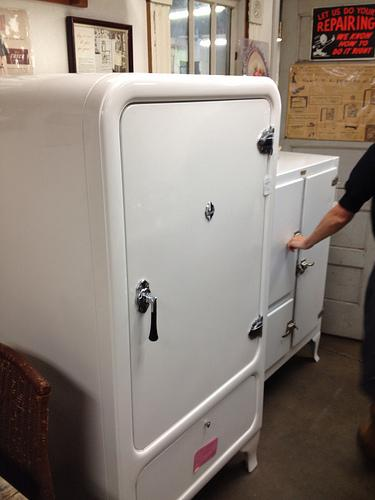Describe the feeling or mood of this image based on the objects present. The image gives a vintage and nostalgic feel due to the antique white refrigerator, the wooden picture frame, and the old-fashioned cupboard. What is the color and material of the handle on the cupboard? The handle is silver in color and made of steel. Identify the type, color, and position of the objects and appliances in the scene. There's a white cupboard with a silver handle, an antique white refrigerator with a pink post-it, a brown chair next to them, a wooden picture frame, a three-pane window, and a sign on the wall with red letters. Mention three significant characteristics of the cupboard and its door. The cupboard is white, has a silver steel handle, and the bottom door of the cupboard has gold hinges. Explain what the person in the image is doing while mentioning their outfit. A person wearing a black shirt is reaching and holding the silver handle of the cupboard, possibly trying to open it. Find the details that describe the window and the sign on the wall. The window has three panes and is positioned above the cabinet. The sign on the wall has red lettering. List three noticeable details about the refrigerator. The refrigerator is an antique, white in color, and has a pink post-it on the bottom door. Point out any unique features and their colors found on the refrigerator. The refrigerator has a pink post-it and a silver handle which contrasts with its white color. What actions are being taken by the person, and what specific object are they interacting with? The person is reaching for and holding the silver handle on the cupboard, apparently trying to open it. Count the number of objects in the image and describe their color and function. There are 9 objects: a white cupboard to store items, a silver handle for opening it, a white antique refrigerator for keeping food, a pink post-it for notes, a brown chair to sit on, a window to let in sunlight, a wooden picture frame for decoration, and a sign with red letters for information. What type of shirt is the person wearing? black shirt Describe any notable features of the door on the cupboard. It has metal or gold hinges. What is the overall style of the kitchen appliances? antique or vintage Describe the material and color of the handle on the cupboard. The handle is silver and made of metal or steel. What is written on the pink post-it on the refrigerator? The text on the post-it is not provided or visible. Explain how you would interpret the scene displayed in the image. A person in a retro-style kitchen is attempting to open a cupboard or refrigerator with a white antique design while surrounded by various other items. What are the key elements in the background of the image? a window, a picture frame, and a sign on the wall Examine the color and material of the appliance. The appliance is white and made of metal. Which feature of the refrigerator indicates its age? The antique design. Identify the color of the chair next to the cupboard. brown Which one of the following objects is on the refrigerator? A) Green Sticker B) Pink Post-it C) Orange Magnet B) Pink Post-it Describe the emotions visible on the person's face in the image. Not applicable, the image does not show a person's face. Identify the primary materials of the objects in the image. The cupboard and frame are wooden, the handle and refrigerator are made of metal, and the post-it is paper. What type of writing can be found on the sign? red lettering Identify the main event happening in the image. A person is reaching for a handle on the cupboard or refrigerator. Is there a window with four panes behind the cupboard? This instruction is misleading because the window mentioned has three panes, not four. Examine the key features of the objects in the image and describe their characteristics. The antique refrigerator has a metal handle, a pink post-it, and is white. The picture frame is wooden and dark brown. The chair is brown with a wooden back. The sign on the wall has red lettering. Is there a green post-it note on the refrigerator door? This instruction is misleading because the post-it note mentioned is pink, not green. What is the color of the cupboard in the scene? white Is there a blue cupboard in the image? The instruction is misleading because there is only a white cupboard mentioned in the image details. Can you find the golden handle on the cupboard? This instruction is misleading because the handle mentioned is silver, not golden. Does the window have multiple panes? Yes, it has three panes. Can you find a purple sticker on the refrigerator? This instruction is misleading because the sticker mentioned is red, not purple. What is the person in the image trying to accomplish? The person is reaching for a handle to open the cupboard or refrigerator. Please provide a brief description of this scene from a creative perspective. A nostalgic kitchen with an antique white refrigerator, adorned by a pink post-it, and a wooden chair taking rest near a windowpane that lets the sun peek through. Can you see a person wearing a red shirt in the image? The instruction is misleading because the person mentioned is wearing a black shirt, not a red shirt. 